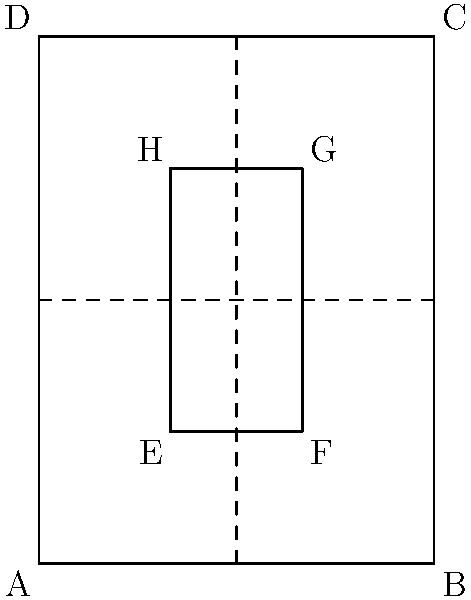As a seasoned Broadway actress, you're familiar with playbills. Consider a playbill folding pattern as shown in the diagram. The outer rectangle ABCD represents the playbill, and the inner rectangle EFGH represents a cutout. The dashed lines indicate fold lines. What is the Euler characteristic of this playbill after all folds are made? Let's approach this step-by-step:

1) First, we need to count the number of vertices (V), edges (E), and faces (F) after folding:

   Vertices (V):
   - The outer corners (A, B, C, D) : 4
   - The inner corners (E, F, G, H) : 4
   - The intersection points of fold lines : 1
   Total V = 9

   Edges (E):
   - Outer edges : 4
   - Inner edges : 4
   - Fold lines : 4 (each fold line is split into two edges by the intersection)
   Total E = 12

   Faces (F):
   - After folding, we have 4 faces (the playbill is folded into quarters)
   Total F = 4

2) The Euler characteristic (χ) is calculated using the formula:
   
   $$χ = V - E + F$$

3) Substituting our values:

   $$χ = 9 - 12 + 4 = 1$$

Therefore, the Euler characteristic of the folded playbill is 1.
Answer: 1 